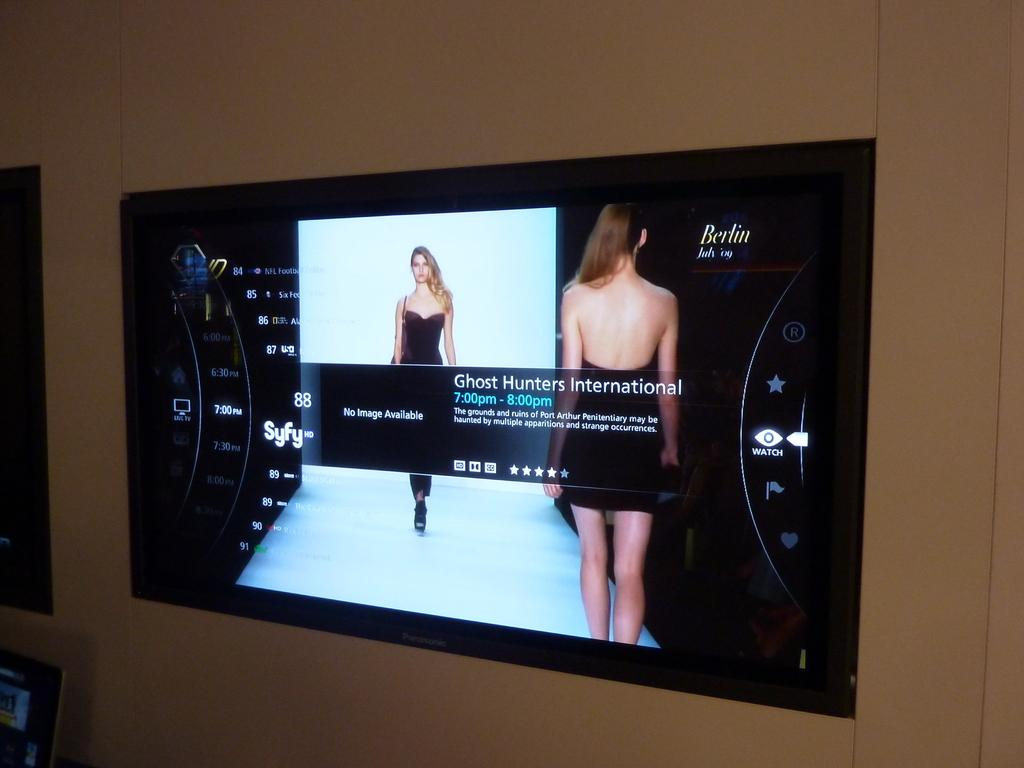<image>
Share a concise interpretation of the image provided. A screen is showing a model from the front and back with TV show information on the Syfy channel about Ghost Hunters International. 